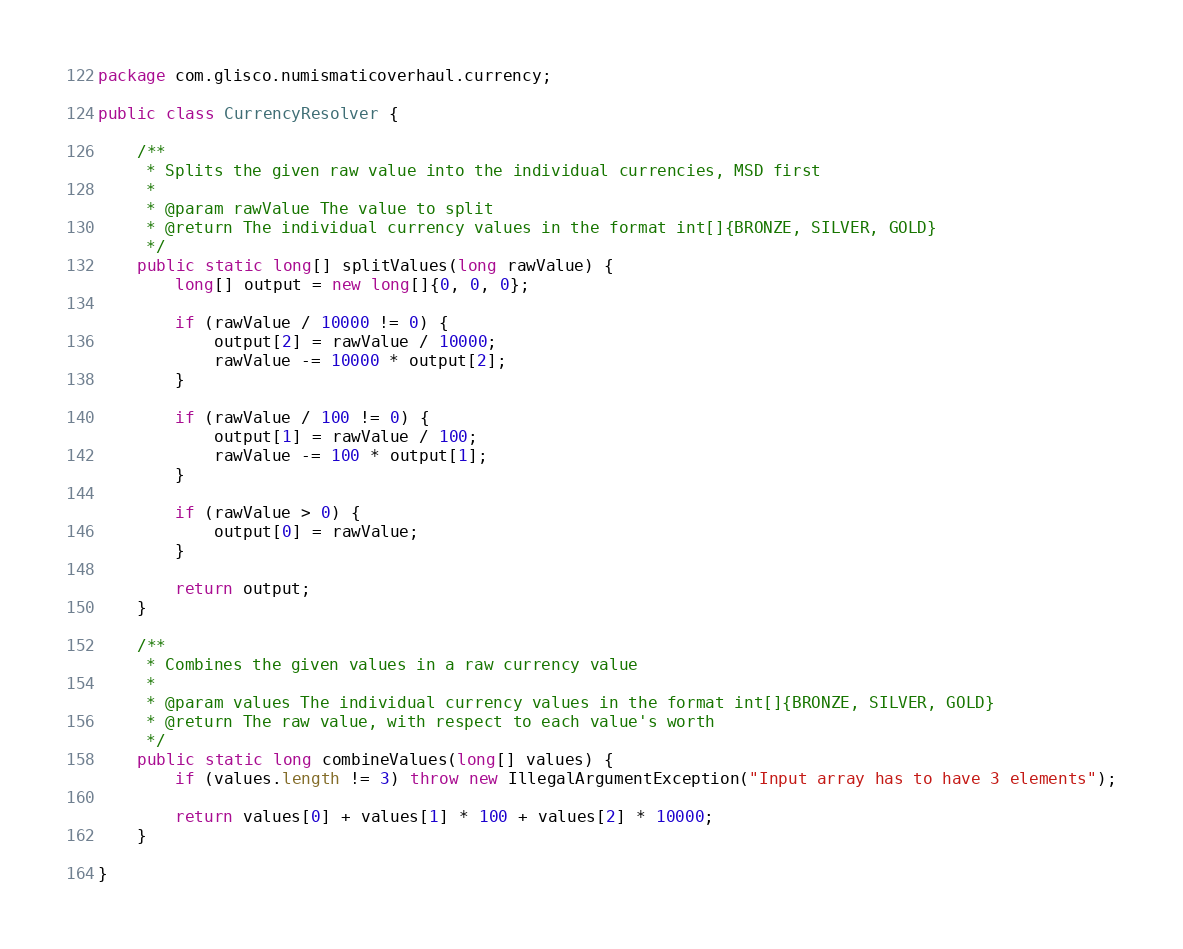<code> <loc_0><loc_0><loc_500><loc_500><_Java_>package com.glisco.numismaticoverhaul.currency;

public class CurrencyResolver {

    /**
     * Splits the given raw value into the individual currencies, MSD first
     *
     * @param rawValue The value to split
     * @return The individual currency values in the format int[]{BRONZE, SILVER, GOLD}
     */
    public static long[] splitValues(long rawValue) {
        long[] output = new long[]{0, 0, 0};

        if (rawValue / 10000 != 0) {
            output[2] = rawValue / 10000;
            rawValue -= 10000 * output[2];
        }

        if (rawValue / 100 != 0) {
            output[1] = rawValue / 100;
            rawValue -= 100 * output[1];
        }

        if (rawValue > 0) {
            output[0] = rawValue;
        }

        return output;
    }

    /**
     * Combines the given values in a raw currency value
     *
     * @param values The individual currency values in the format int[]{BRONZE, SILVER, GOLD}
     * @return The raw value, with respect to each value's worth
     */
    public static long combineValues(long[] values) {
        if (values.length != 3) throw new IllegalArgumentException("Input array has to have 3 elements");

        return values[0] + values[1] * 100 + values[2] * 10000;
    }

}
</code> 